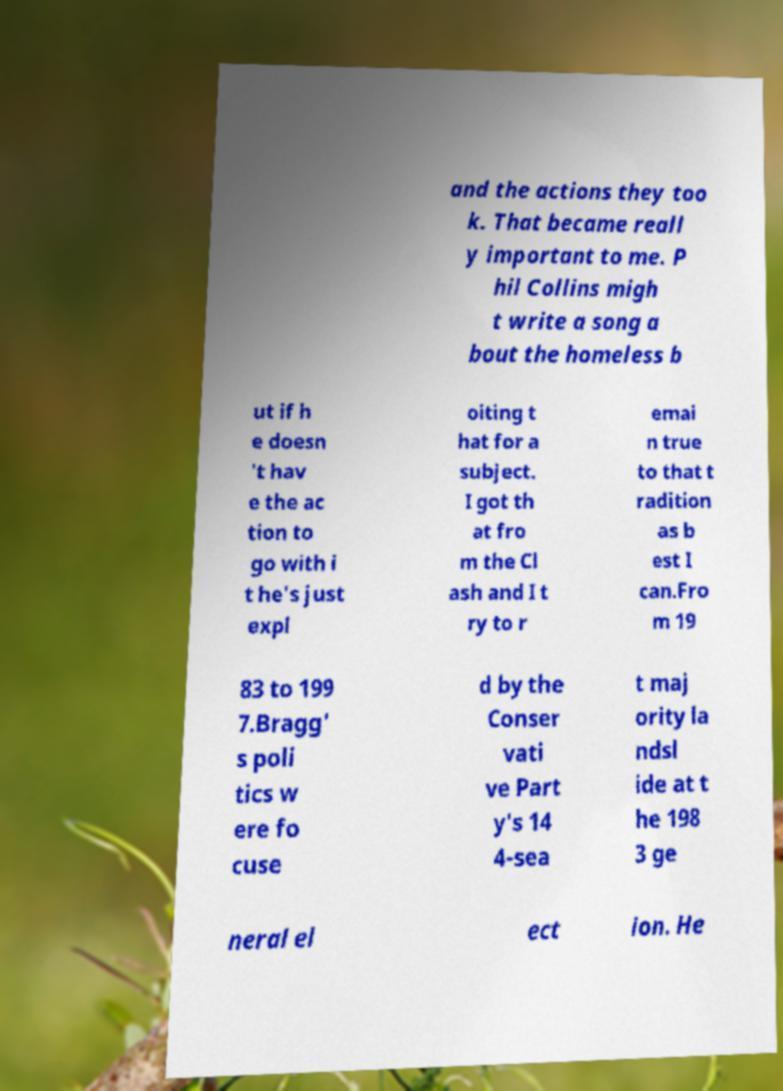For documentation purposes, I need the text within this image transcribed. Could you provide that? and the actions they too k. That became reall y important to me. P hil Collins migh t write a song a bout the homeless b ut if h e doesn 't hav e the ac tion to go with i t he's just expl oiting t hat for a subject. I got th at fro m the Cl ash and I t ry to r emai n true to that t radition as b est I can.Fro m 19 83 to 199 7.Bragg' s poli tics w ere fo cuse d by the Conser vati ve Part y's 14 4-sea t maj ority la ndsl ide at t he 198 3 ge neral el ect ion. He 